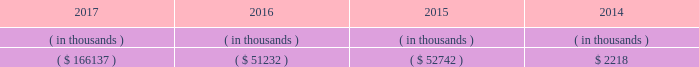Entergy arkansas 2019s receivables from or ( payables to ) the money pool were as follows as of december 31 for each of the following years. .
See note 4 to the financial statements for a description of the money pool .
Entergy arkansas has a credit facility in the amount of $ 150 million scheduled to expire in august 2022 .
Entergy arkansas also has a $ 20 million credit facility scheduled to expire in april 2018 . a0 a0the $ 150 million credit facility permits the issuance of letters of credit against $ 5 million of the borrowing capacity of the facility .
As of december 31 , 2017 , there were no cash borrowings and no letters of credit outstanding under the credit facilities .
In addition , entergy arkansas is a party to an uncommitted letter of credit facility as a means to post collateral to support its obligations to miso .
As of december 31 , 2017 , a $ 1 million letter of credit was outstanding under entergy arkansas 2019s uncommitted letter of credit facility .
See note 4 to the financial statements for further discussion of the credit facilities .
The entergy arkansas nuclear fuel company variable interest entity has a credit facility in the amount of $ 80 million scheduled to expire in may 2019 . a0 a0as of december 31 , 2017 , $ 50 million in letters of credit to support a like amount of commercial paper issued and $ 24.9 million in loans were outstanding under the entergy arkansas nuclear fuel company variable interest entity credit facility .
See note 4 to the financial statements for further discussion of the nuclear fuel company variable interest entity credit facility .
Entergy arkansas obtained authorizations from the ferc through october 2019 for short-term borrowings not to exceed an aggregate amount of $ 250 million at any time outstanding and borrowings by its nuclear fuel company variable interest entity .
See note 4 to the financial statements for further discussion of entergy arkansas 2019s short-term borrowing limits .
The long-term securities issuances of entergy arkansas are limited to amounts authorized by the apsc , and the current authorization extends through december 2018 .
Entergy arkansas , inc .
And subsidiaries management 2019s financial discussion and analysis state and local rate regulation and fuel-cost recovery retail rates 2015 base rate filing in april 2015 , entergy arkansas filed with the apsc for a general change in rates , charges , and tariffs .
The filing notified the apsc of entergy arkansas 2019s intent to implement a forward test year formula rate plan pursuant to arkansas legislation passed in 2015 , and requested a retail rate increase of $ 268.4 million , with a net increase in revenue of $ 167 million .
The filing requested a 10.2% ( 10.2 % ) return on common equity .
In september 2015 the apsc staff and intervenors filed direct testimony , with the apsc staff recommending a revenue requirement of $ 217.9 million and a 9.65% ( 9.65 % ) return on common equity .
In december 2015 , entergy arkansas , the apsc staff , and certain of the intervenors in the rate case filed with the apsc a joint motion for approval of a settlement of the case that proposed a retail rate increase of approximately $ 225 million with a net increase in revenue of approximately $ 133 million ; an authorized return on common equity of 9.75% ( 9.75 % ) ; and a formula rate plan tariff that provides a +/- 50 basis point band around the 9.75% ( 9.75 % ) allowed return on common equity .
A significant portion of the rate increase is related to entergy arkansas 2019s acquisition in march 2016 of union power station power block 2 for a base purchase price of $ 237 million .
The settlement agreement also provided for amortization over a 10-year period of $ 7.7 million of previously-incurred costs related to ano post-fukushima compliance and $ 9.9 million of previously-incurred costs related to ano flood barrier compliance .
A settlement hearing was held in january 2016 .
In february 2016 the apsc approved the settlement with one exception that reduced the retail rate increase proposed in the settlement by $ 5 million .
The settling parties agreed to the apsc modifications in february 2016 .
The new rates were effective february 24 , 2016 and began billing with the first billing cycle of april 2016 .
In march 2016 , entergy arkansas made a compliance filing regarding the .
What was the sum of the entergy arkansas 2019s payables from 2015 to 2017 in millions? 
Computations: ((166137 + 51232) + 52742)
Answer: 270111.0. 